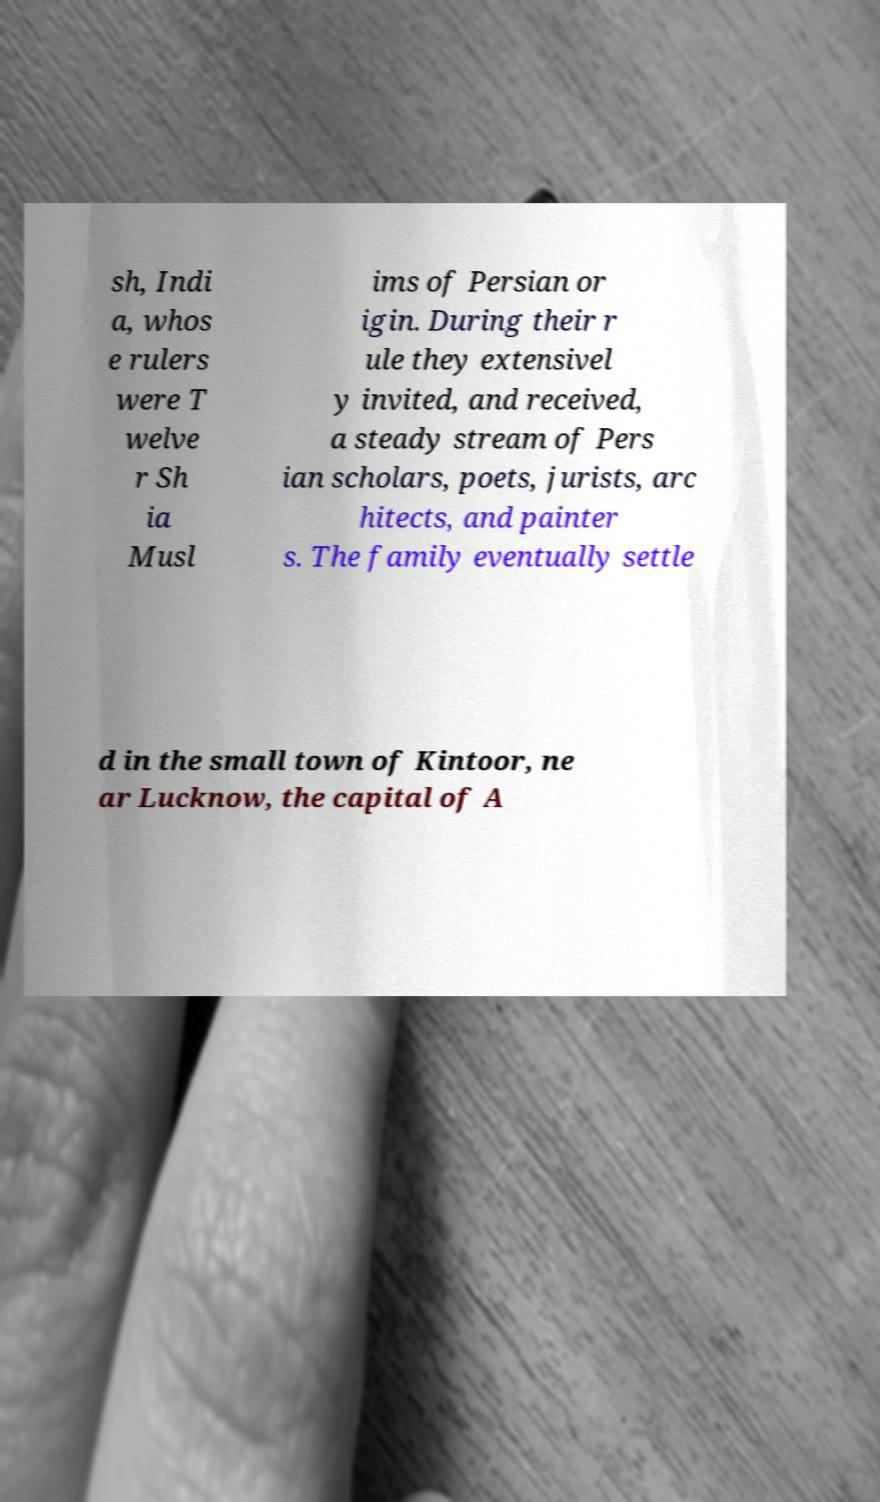Can you read and provide the text displayed in the image?This photo seems to have some interesting text. Can you extract and type it out for me? sh, Indi a, whos e rulers were T welve r Sh ia Musl ims of Persian or igin. During their r ule they extensivel y invited, and received, a steady stream of Pers ian scholars, poets, jurists, arc hitects, and painter s. The family eventually settle d in the small town of Kintoor, ne ar Lucknow, the capital of A 